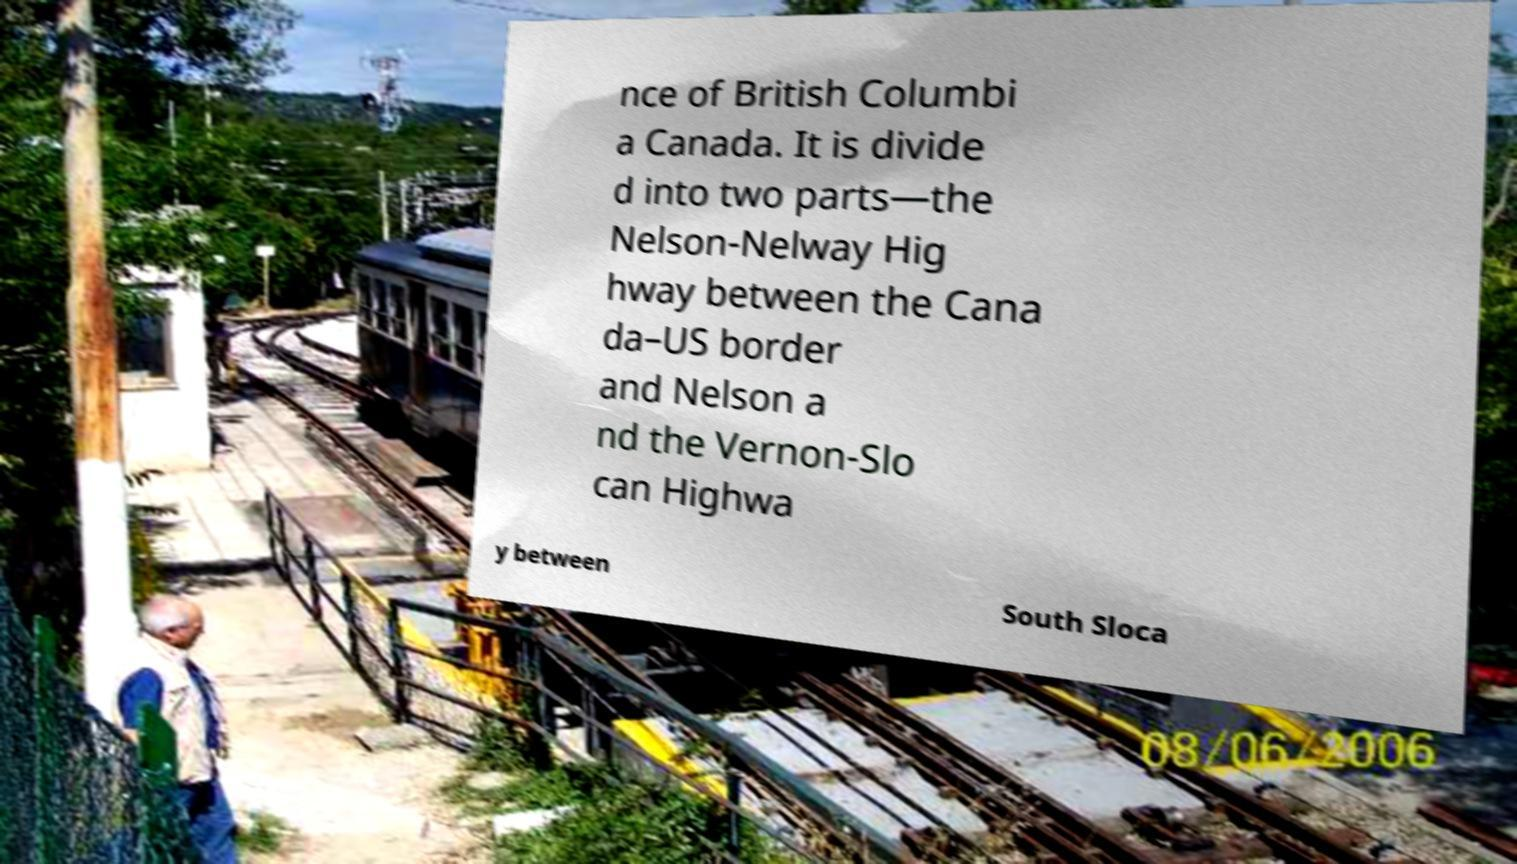Can you read and provide the text displayed in the image?This photo seems to have some interesting text. Can you extract and type it out for me? nce of British Columbi a Canada. It is divide d into two parts—the Nelson-Nelway Hig hway between the Cana da–US border and Nelson a nd the Vernon-Slo can Highwa y between South Sloca 